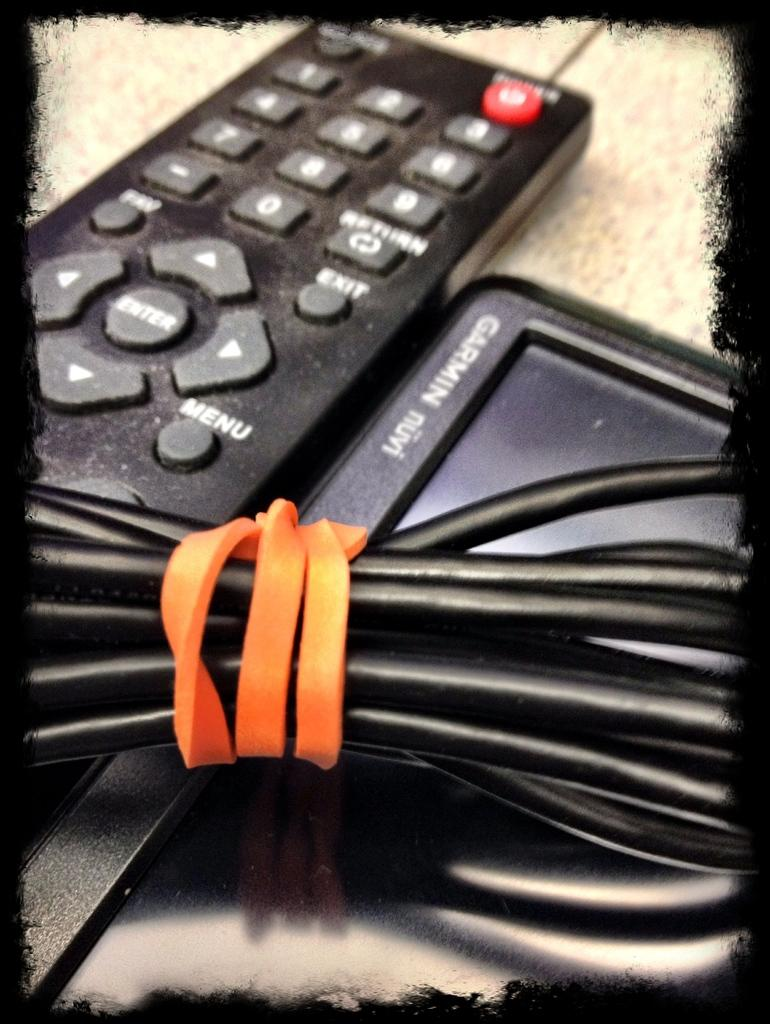Provide a one-sentence caption for the provided image. A black remote sits next to a small screen that has Garmin on the edge. 